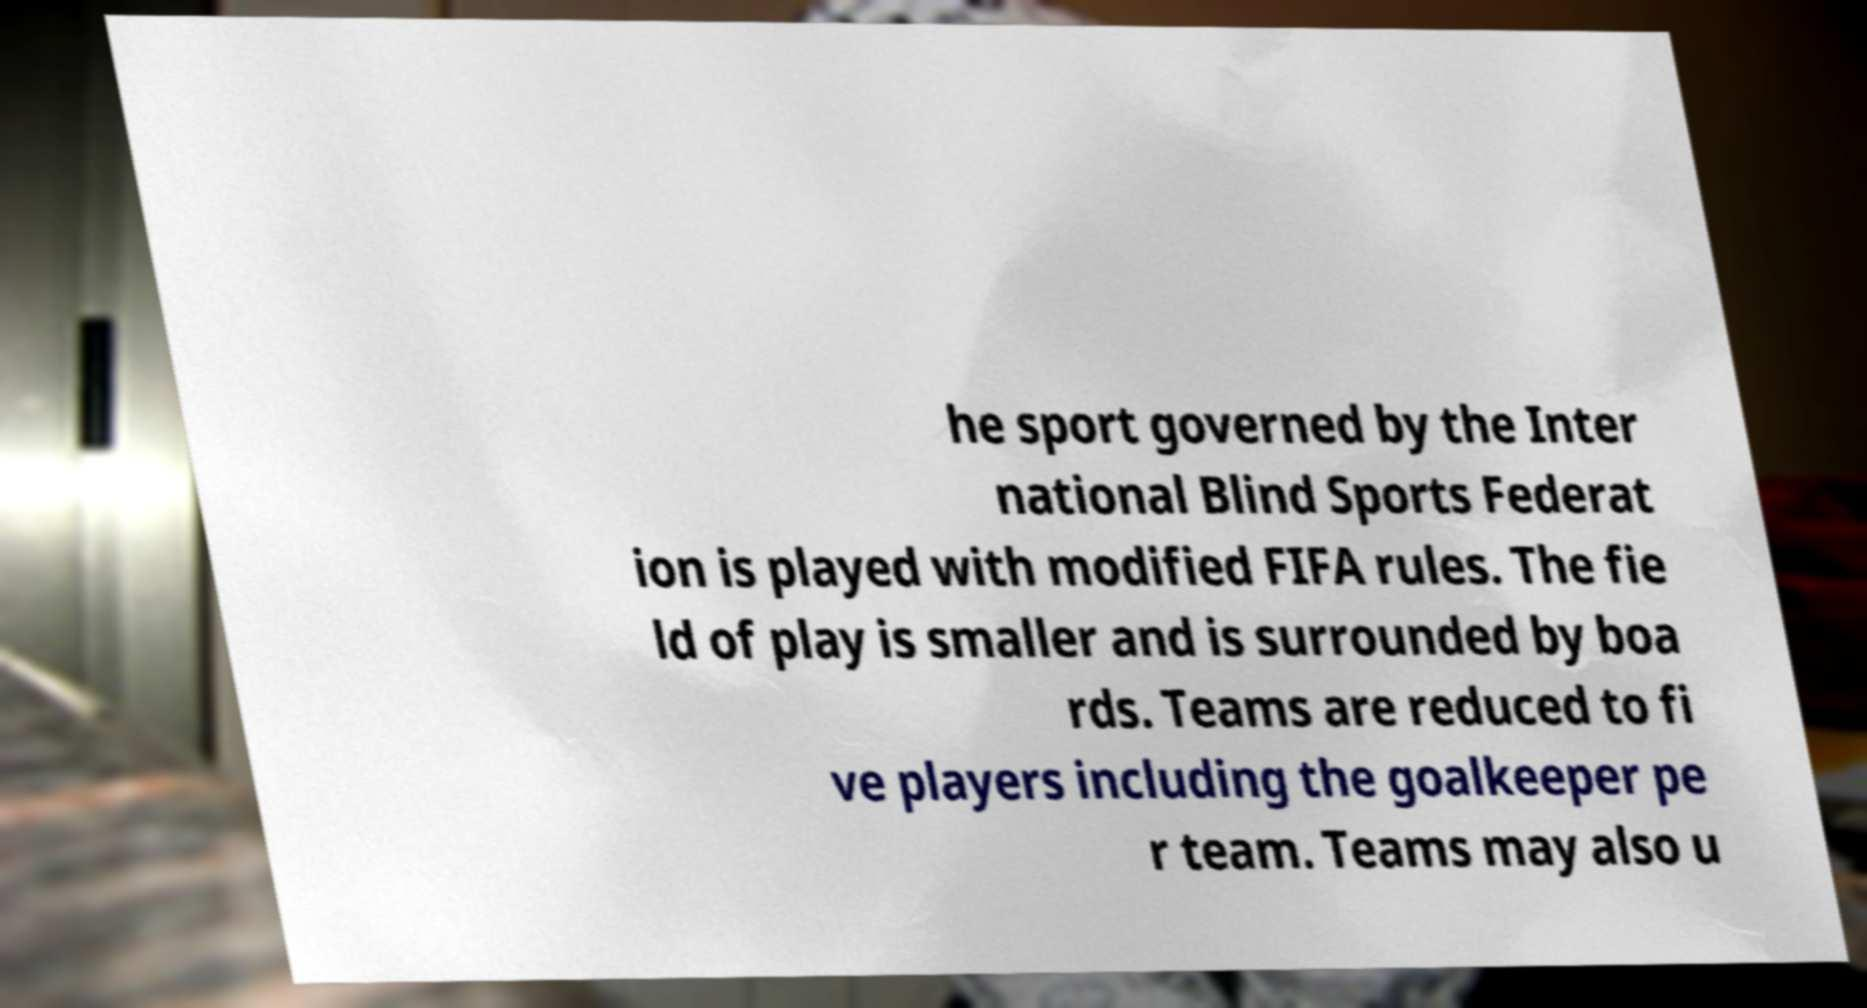Please read and relay the text visible in this image. What does it say? he sport governed by the Inter national Blind Sports Federat ion is played with modified FIFA rules. The fie ld of play is smaller and is surrounded by boa rds. Teams are reduced to fi ve players including the goalkeeper pe r team. Teams may also u 